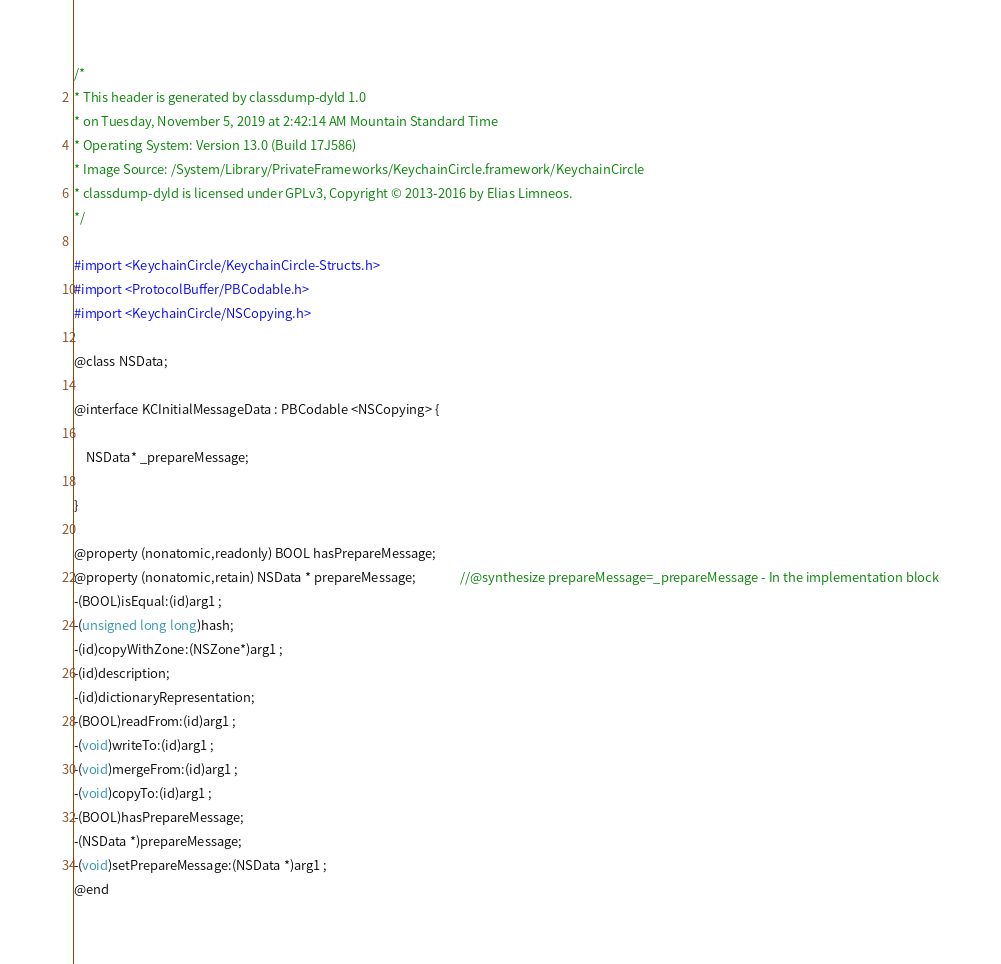Convert code to text. <code><loc_0><loc_0><loc_500><loc_500><_C_>/*
* This header is generated by classdump-dyld 1.0
* on Tuesday, November 5, 2019 at 2:42:14 AM Mountain Standard Time
* Operating System: Version 13.0 (Build 17J586)
* Image Source: /System/Library/PrivateFrameworks/KeychainCircle.framework/KeychainCircle
* classdump-dyld is licensed under GPLv3, Copyright © 2013-2016 by Elias Limneos.
*/

#import <KeychainCircle/KeychainCircle-Structs.h>
#import <ProtocolBuffer/PBCodable.h>
#import <KeychainCircle/NSCopying.h>

@class NSData;

@interface KCInitialMessageData : PBCodable <NSCopying> {

	NSData* _prepareMessage;

}

@property (nonatomic,readonly) BOOL hasPrepareMessage; 
@property (nonatomic,retain) NSData * prepareMessage;               //@synthesize prepareMessage=_prepareMessage - In the implementation block
-(BOOL)isEqual:(id)arg1 ;
-(unsigned long long)hash;
-(id)copyWithZone:(NSZone*)arg1 ;
-(id)description;
-(id)dictionaryRepresentation;
-(BOOL)readFrom:(id)arg1 ;
-(void)writeTo:(id)arg1 ;
-(void)mergeFrom:(id)arg1 ;
-(void)copyTo:(id)arg1 ;
-(BOOL)hasPrepareMessage;
-(NSData *)prepareMessage;
-(void)setPrepareMessage:(NSData *)arg1 ;
@end

</code> 